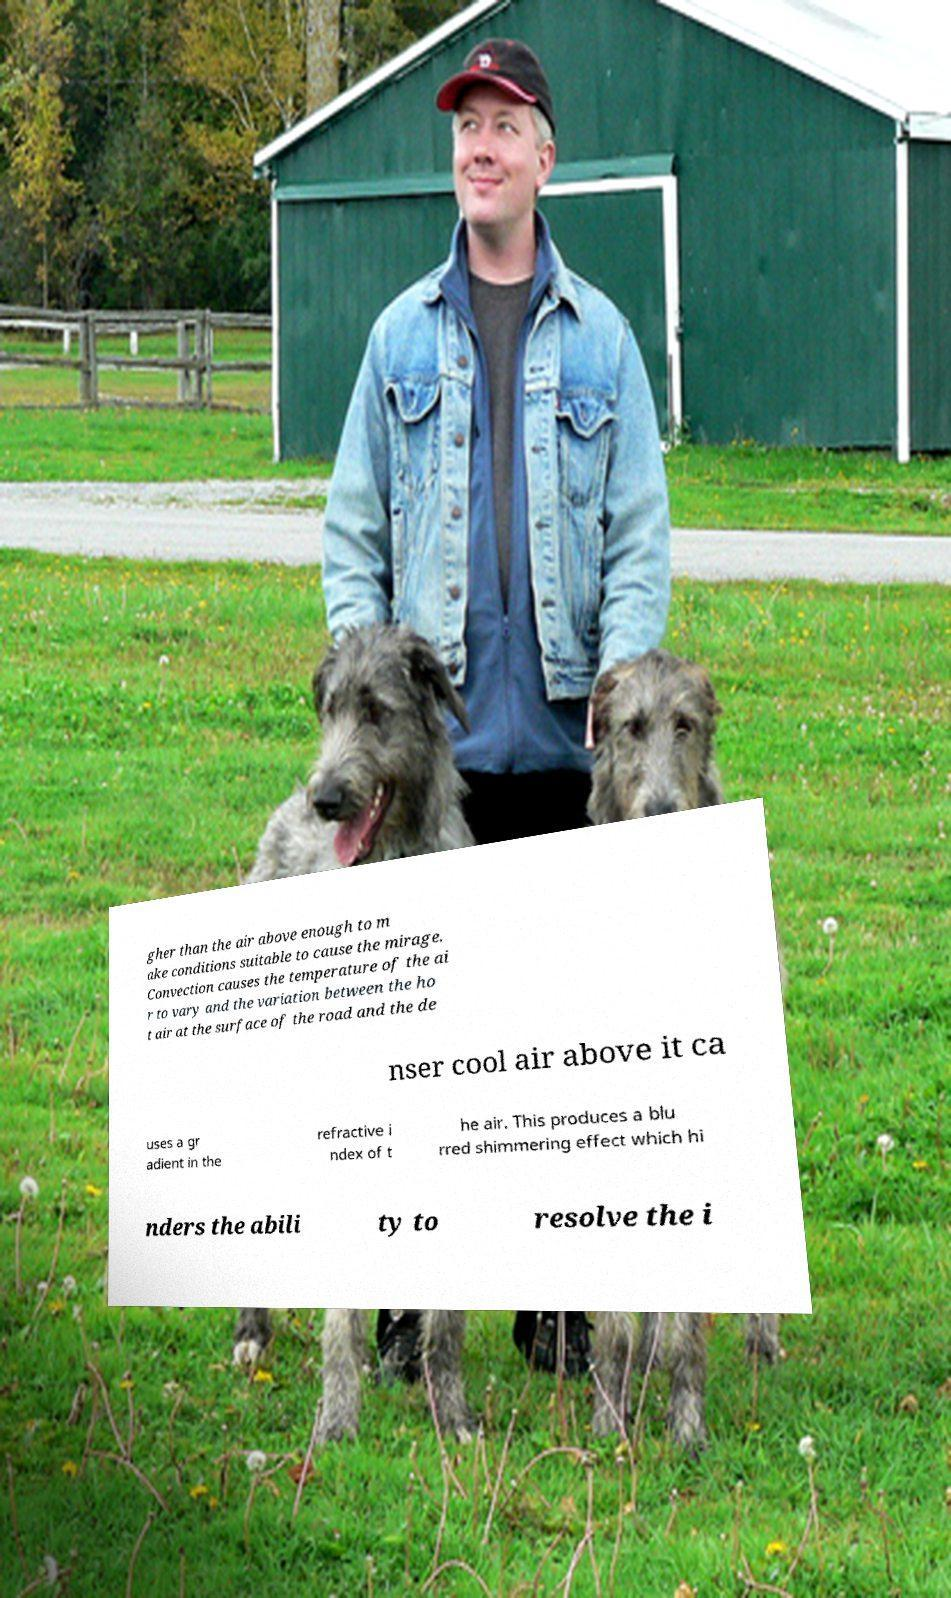Can you read and provide the text displayed in the image?This photo seems to have some interesting text. Can you extract and type it out for me? gher than the air above enough to m ake conditions suitable to cause the mirage. Convection causes the temperature of the ai r to vary and the variation between the ho t air at the surface of the road and the de nser cool air above it ca uses a gr adient in the refractive i ndex of t he air. This produces a blu rred shimmering effect which hi nders the abili ty to resolve the i 